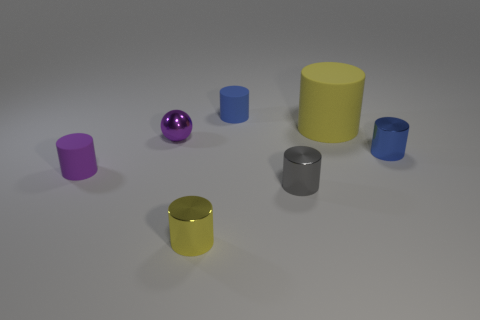Subtract 1 cylinders. How many cylinders are left? 5 Subtract all small gray metallic cylinders. How many cylinders are left? 5 Subtract all blue cylinders. How many cylinders are left? 4 Subtract all blue cylinders. Subtract all cyan blocks. How many cylinders are left? 4 Add 2 small yellow metallic objects. How many objects exist? 9 Subtract all cylinders. How many objects are left? 1 Add 7 blue metallic cylinders. How many blue metallic cylinders are left? 8 Add 2 small purple rubber cylinders. How many small purple rubber cylinders exist? 3 Subtract 0 gray cubes. How many objects are left? 7 Subtract all small blue cylinders. Subtract all tiny purple rubber objects. How many objects are left? 4 